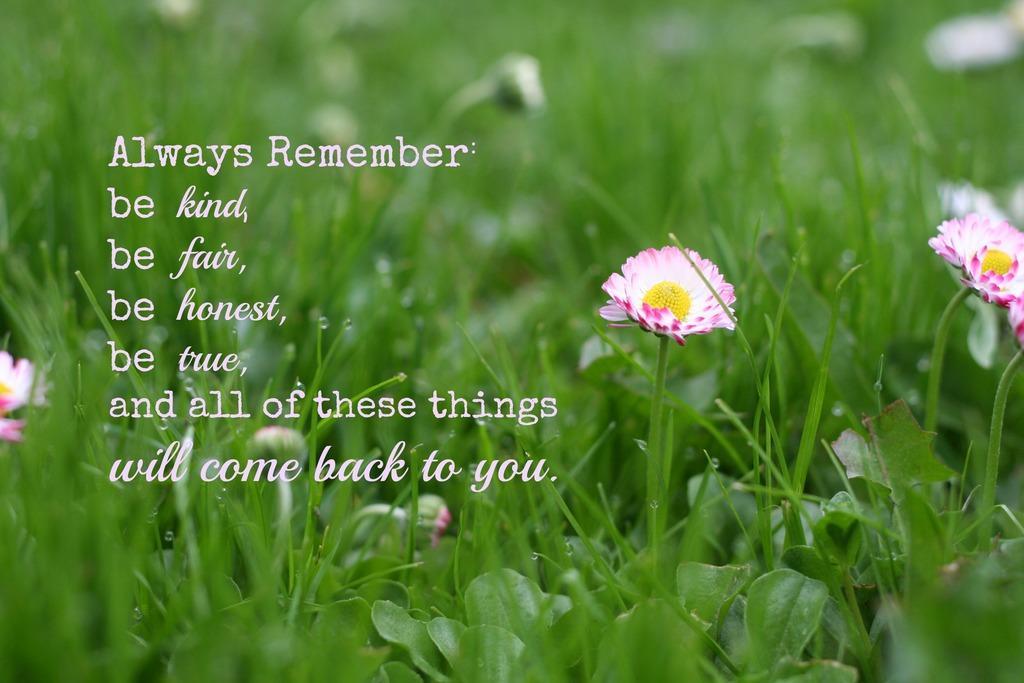Can you describe this image briefly? Something written on this image. Here we can see grass, plant and flowers. Background it is blur. 